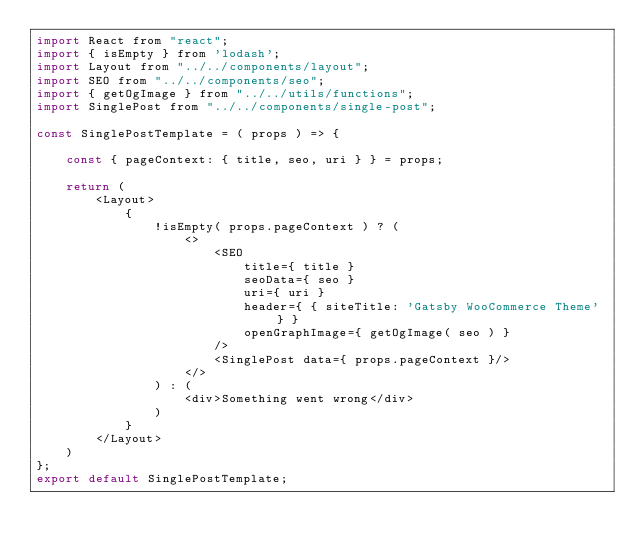Convert code to text. <code><loc_0><loc_0><loc_500><loc_500><_JavaScript_>import React from "react";
import { isEmpty } from 'lodash';
import Layout from "../../components/layout";
import SEO from "../../components/seo";
import { getOgImage } from "../../utils/functions";
import SinglePost from "../../components/single-post";

const SinglePostTemplate = ( props ) => {

	const { pageContext: { title, seo, uri } } = props;

	return (
		<Layout>
			{
				!isEmpty( props.pageContext ) ? (
					<>
						<SEO
							title={ title }
							seoData={ seo }
							uri={ uri }
							header={ { siteTitle: 'Gatsby WooCommerce Theme' } }
							openGraphImage={ getOgImage( seo ) }
						/>
						<SinglePost data={ props.pageContext }/>
					</>
				) : (
					<div>Something went wrong</div>
				)
			}
		</Layout>
	)
};
export default SinglePostTemplate;

</code> 